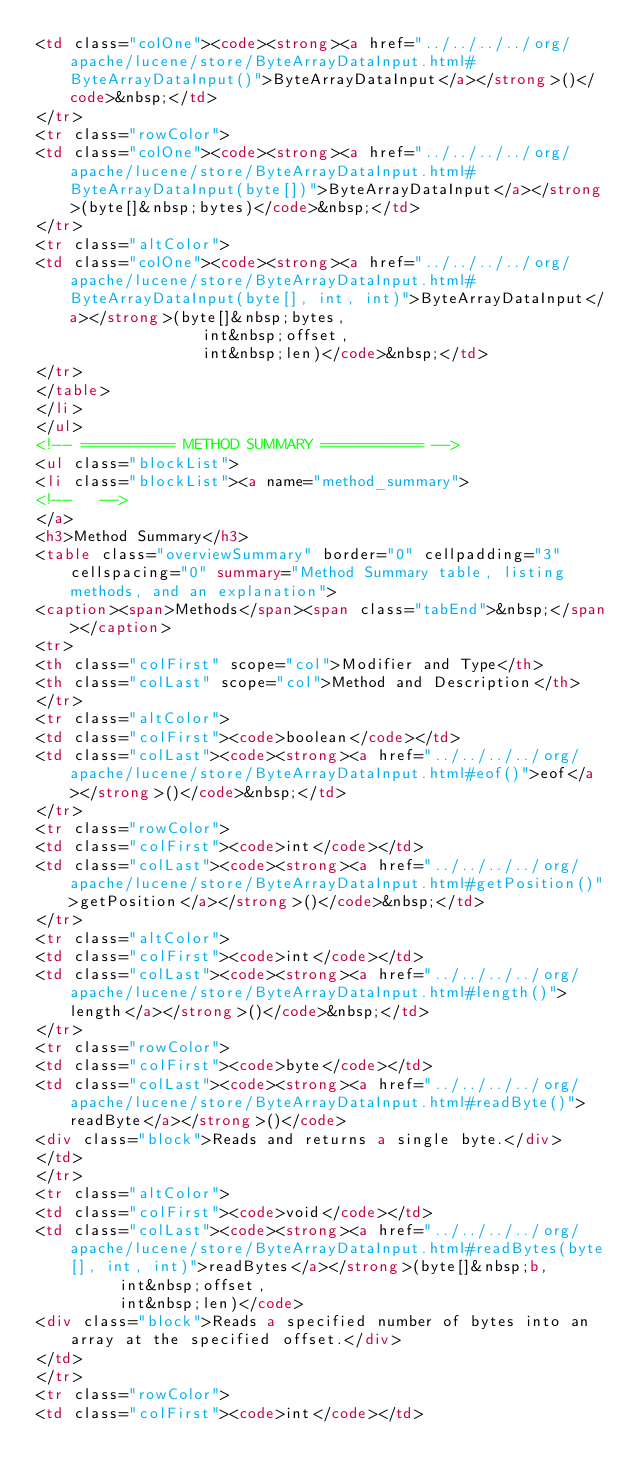<code> <loc_0><loc_0><loc_500><loc_500><_HTML_><td class="colOne"><code><strong><a href="../../../../org/apache/lucene/store/ByteArrayDataInput.html#ByteArrayDataInput()">ByteArrayDataInput</a></strong>()</code>&nbsp;</td>
</tr>
<tr class="rowColor">
<td class="colOne"><code><strong><a href="../../../../org/apache/lucene/store/ByteArrayDataInput.html#ByteArrayDataInput(byte[])">ByteArrayDataInput</a></strong>(byte[]&nbsp;bytes)</code>&nbsp;</td>
</tr>
<tr class="altColor">
<td class="colOne"><code><strong><a href="../../../../org/apache/lucene/store/ByteArrayDataInput.html#ByteArrayDataInput(byte[], int, int)">ByteArrayDataInput</a></strong>(byte[]&nbsp;bytes,
                  int&nbsp;offset,
                  int&nbsp;len)</code>&nbsp;</td>
</tr>
</table>
</li>
</ul>
<!-- ========== METHOD SUMMARY =========== -->
<ul class="blockList">
<li class="blockList"><a name="method_summary">
<!--   -->
</a>
<h3>Method Summary</h3>
<table class="overviewSummary" border="0" cellpadding="3" cellspacing="0" summary="Method Summary table, listing methods, and an explanation">
<caption><span>Methods</span><span class="tabEnd">&nbsp;</span></caption>
<tr>
<th class="colFirst" scope="col">Modifier and Type</th>
<th class="colLast" scope="col">Method and Description</th>
</tr>
<tr class="altColor">
<td class="colFirst"><code>boolean</code></td>
<td class="colLast"><code><strong><a href="../../../../org/apache/lucene/store/ByteArrayDataInput.html#eof()">eof</a></strong>()</code>&nbsp;</td>
</tr>
<tr class="rowColor">
<td class="colFirst"><code>int</code></td>
<td class="colLast"><code><strong><a href="../../../../org/apache/lucene/store/ByteArrayDataInput.html#getPosition()">getPosition</a></strong>()</code>&nbsp;</td>
</tr>
<tr class="altColor">
<td class="colFirst"><code>int</code></td>
<td class="colLast"><code><strong><a href="../../../../org/apache/lucene/store/ByteArrayDataInput.html#length()">length</a></strong>()</code>&nbsp;</td>
</tr>
<tr class="rowColor">
<td class="colFirst"><code>byte</code></td>
<td class="colLast"><code><strong><a href="../../../../org/apache/lucene/store/ByteArrayDataInput.html#readByte()">readByte</a></strong>()</code>
<div class="block">Reads and returns a single byte.</div>
</td>
</tr>
<tr class="altColor">
<td class="colFirst"><code>void</code></td>
<td class="colLast"><code><strong><a href="../../../../org/apache/lucene/store/ByteArrayDataInput.html#readBytes(byte[], int, int)">readBytes</a></strong>(byte[]&nbsp;b,
         int&nbsp;offset,
         int&nbsp;len)</code>
<div class="block">Reads a specified number of bytes into an array at the specified offset.</div>
</td>
</tr>
<tr class="rowColor">
<td class="colFirst"><code>int</code></td></code> 